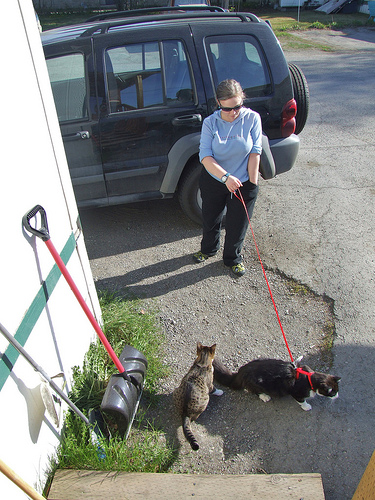<image>
Can you confirm if the cat is on the leash? Yes. Looking at the image, I can see the cat is positioned on top of the leash, with the leash providing support. Is there a cat under the woman? No. The cat is not positioned under the woman. The vertical relationship between these objects is different. 